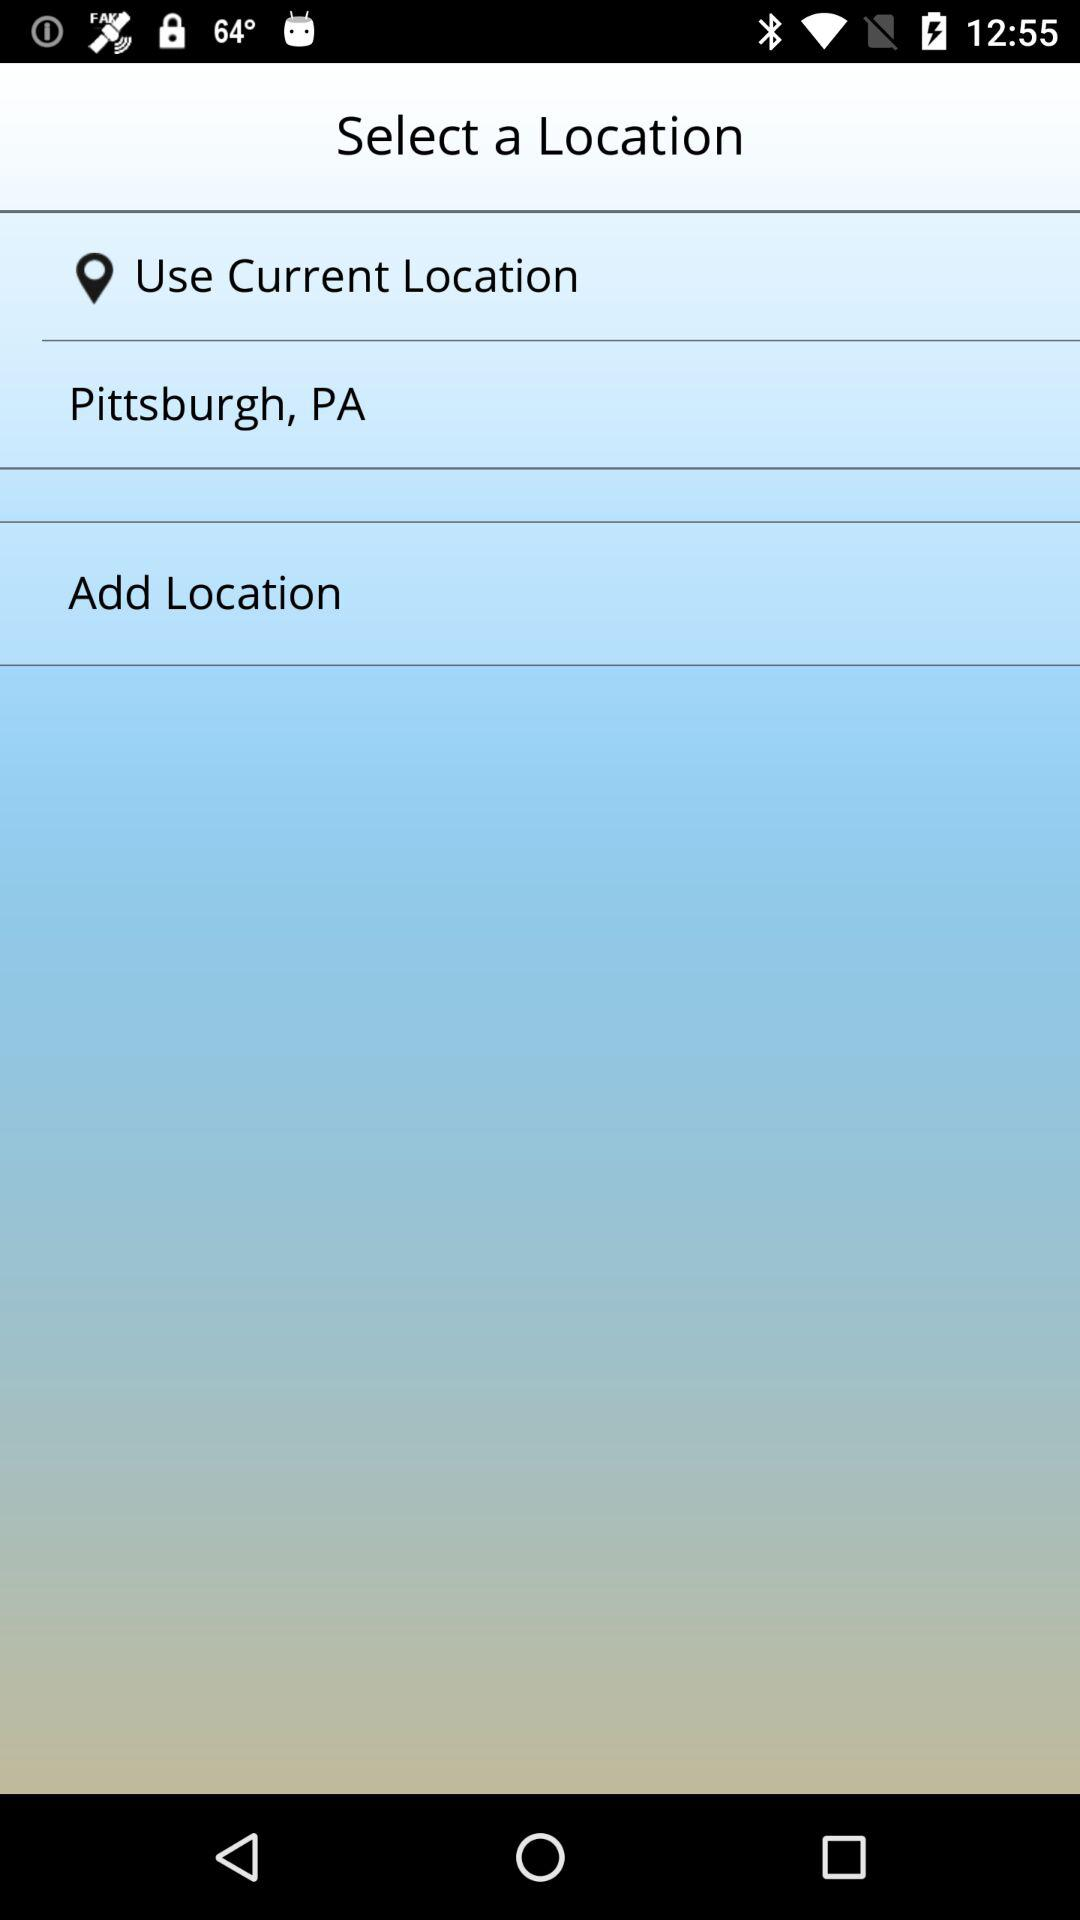What is the selected current location? The selected current location is Pittsburgh, PA. 